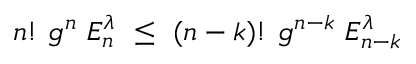<formula> <loc_0><loc_0><loc_500><loc_500>n ! g ^ { n } E _ { n } ^ { \lambda } \leq ( n - k ) ! g ^ { n - k } E _ { n - k } ^ { \lambda }</formula> 